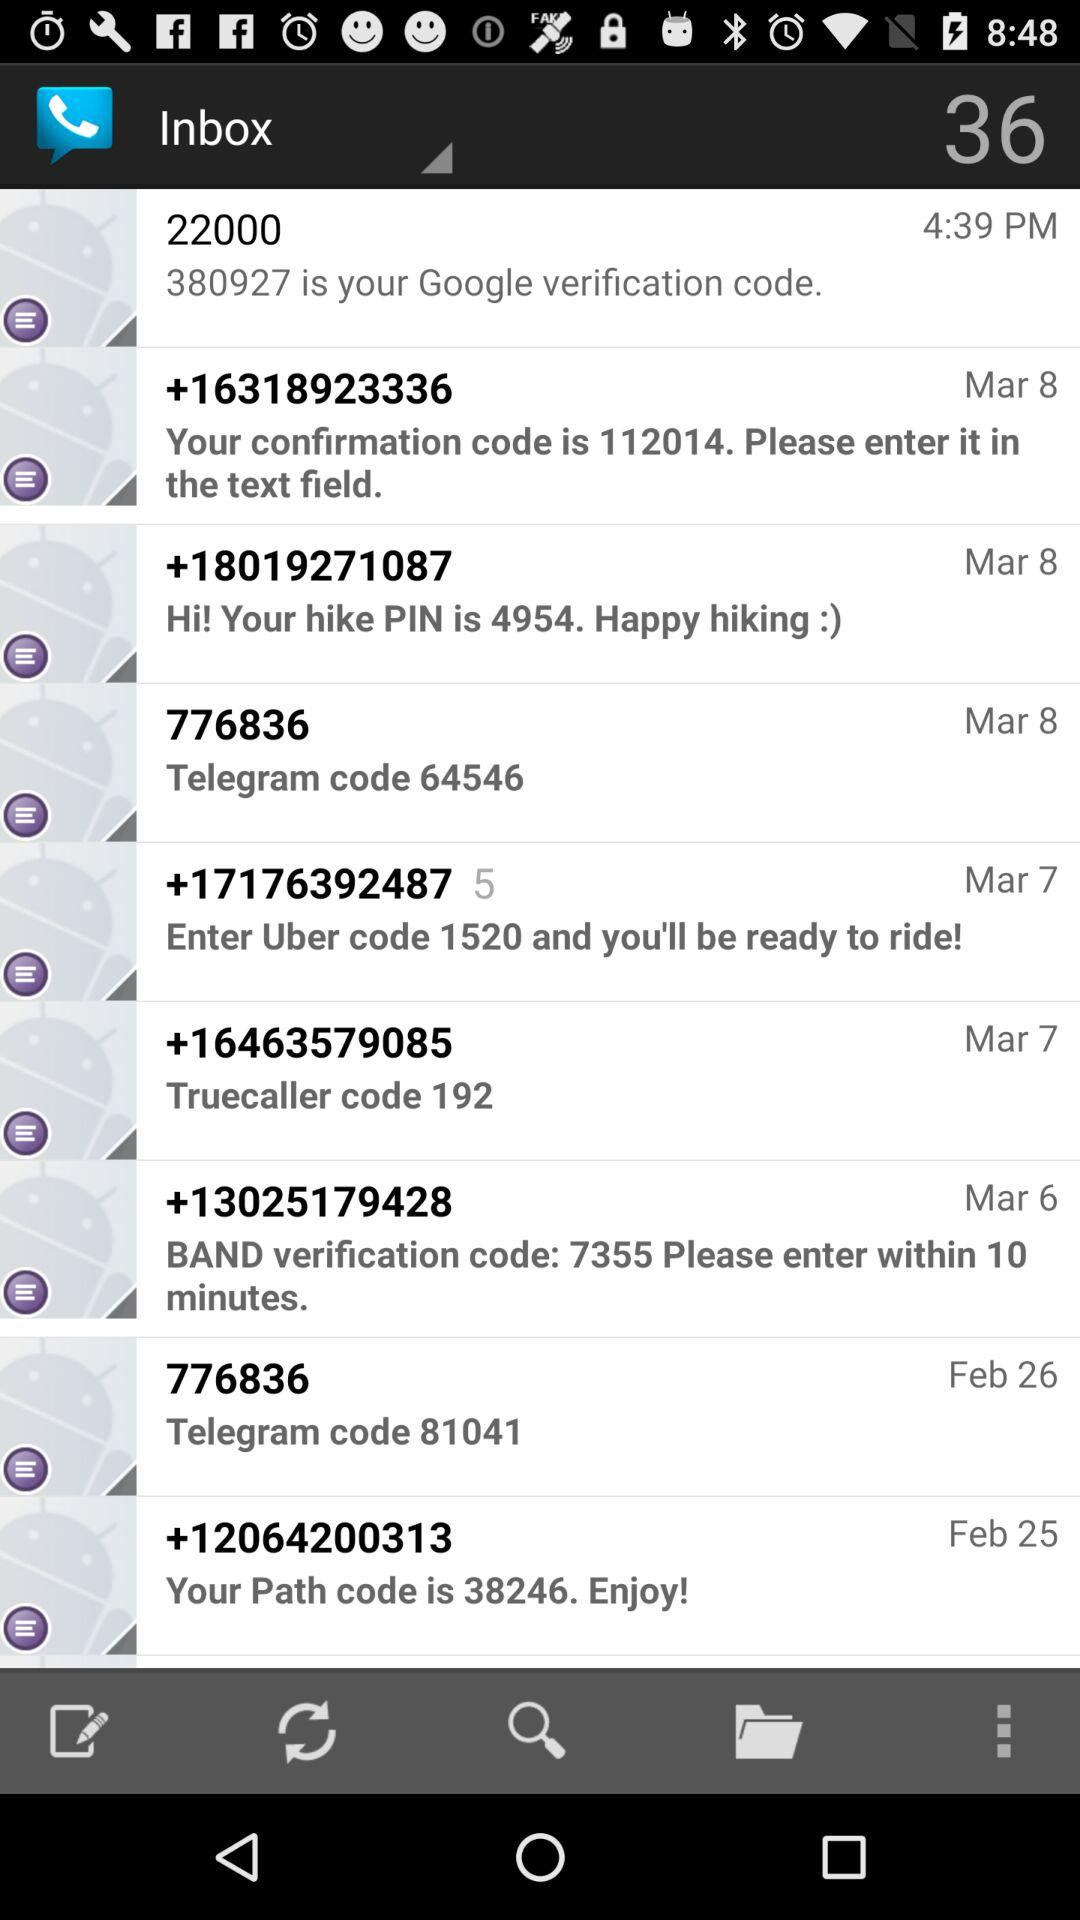How many text messages are there in the inbox?
Answer the question using a single word or phrase. 9 